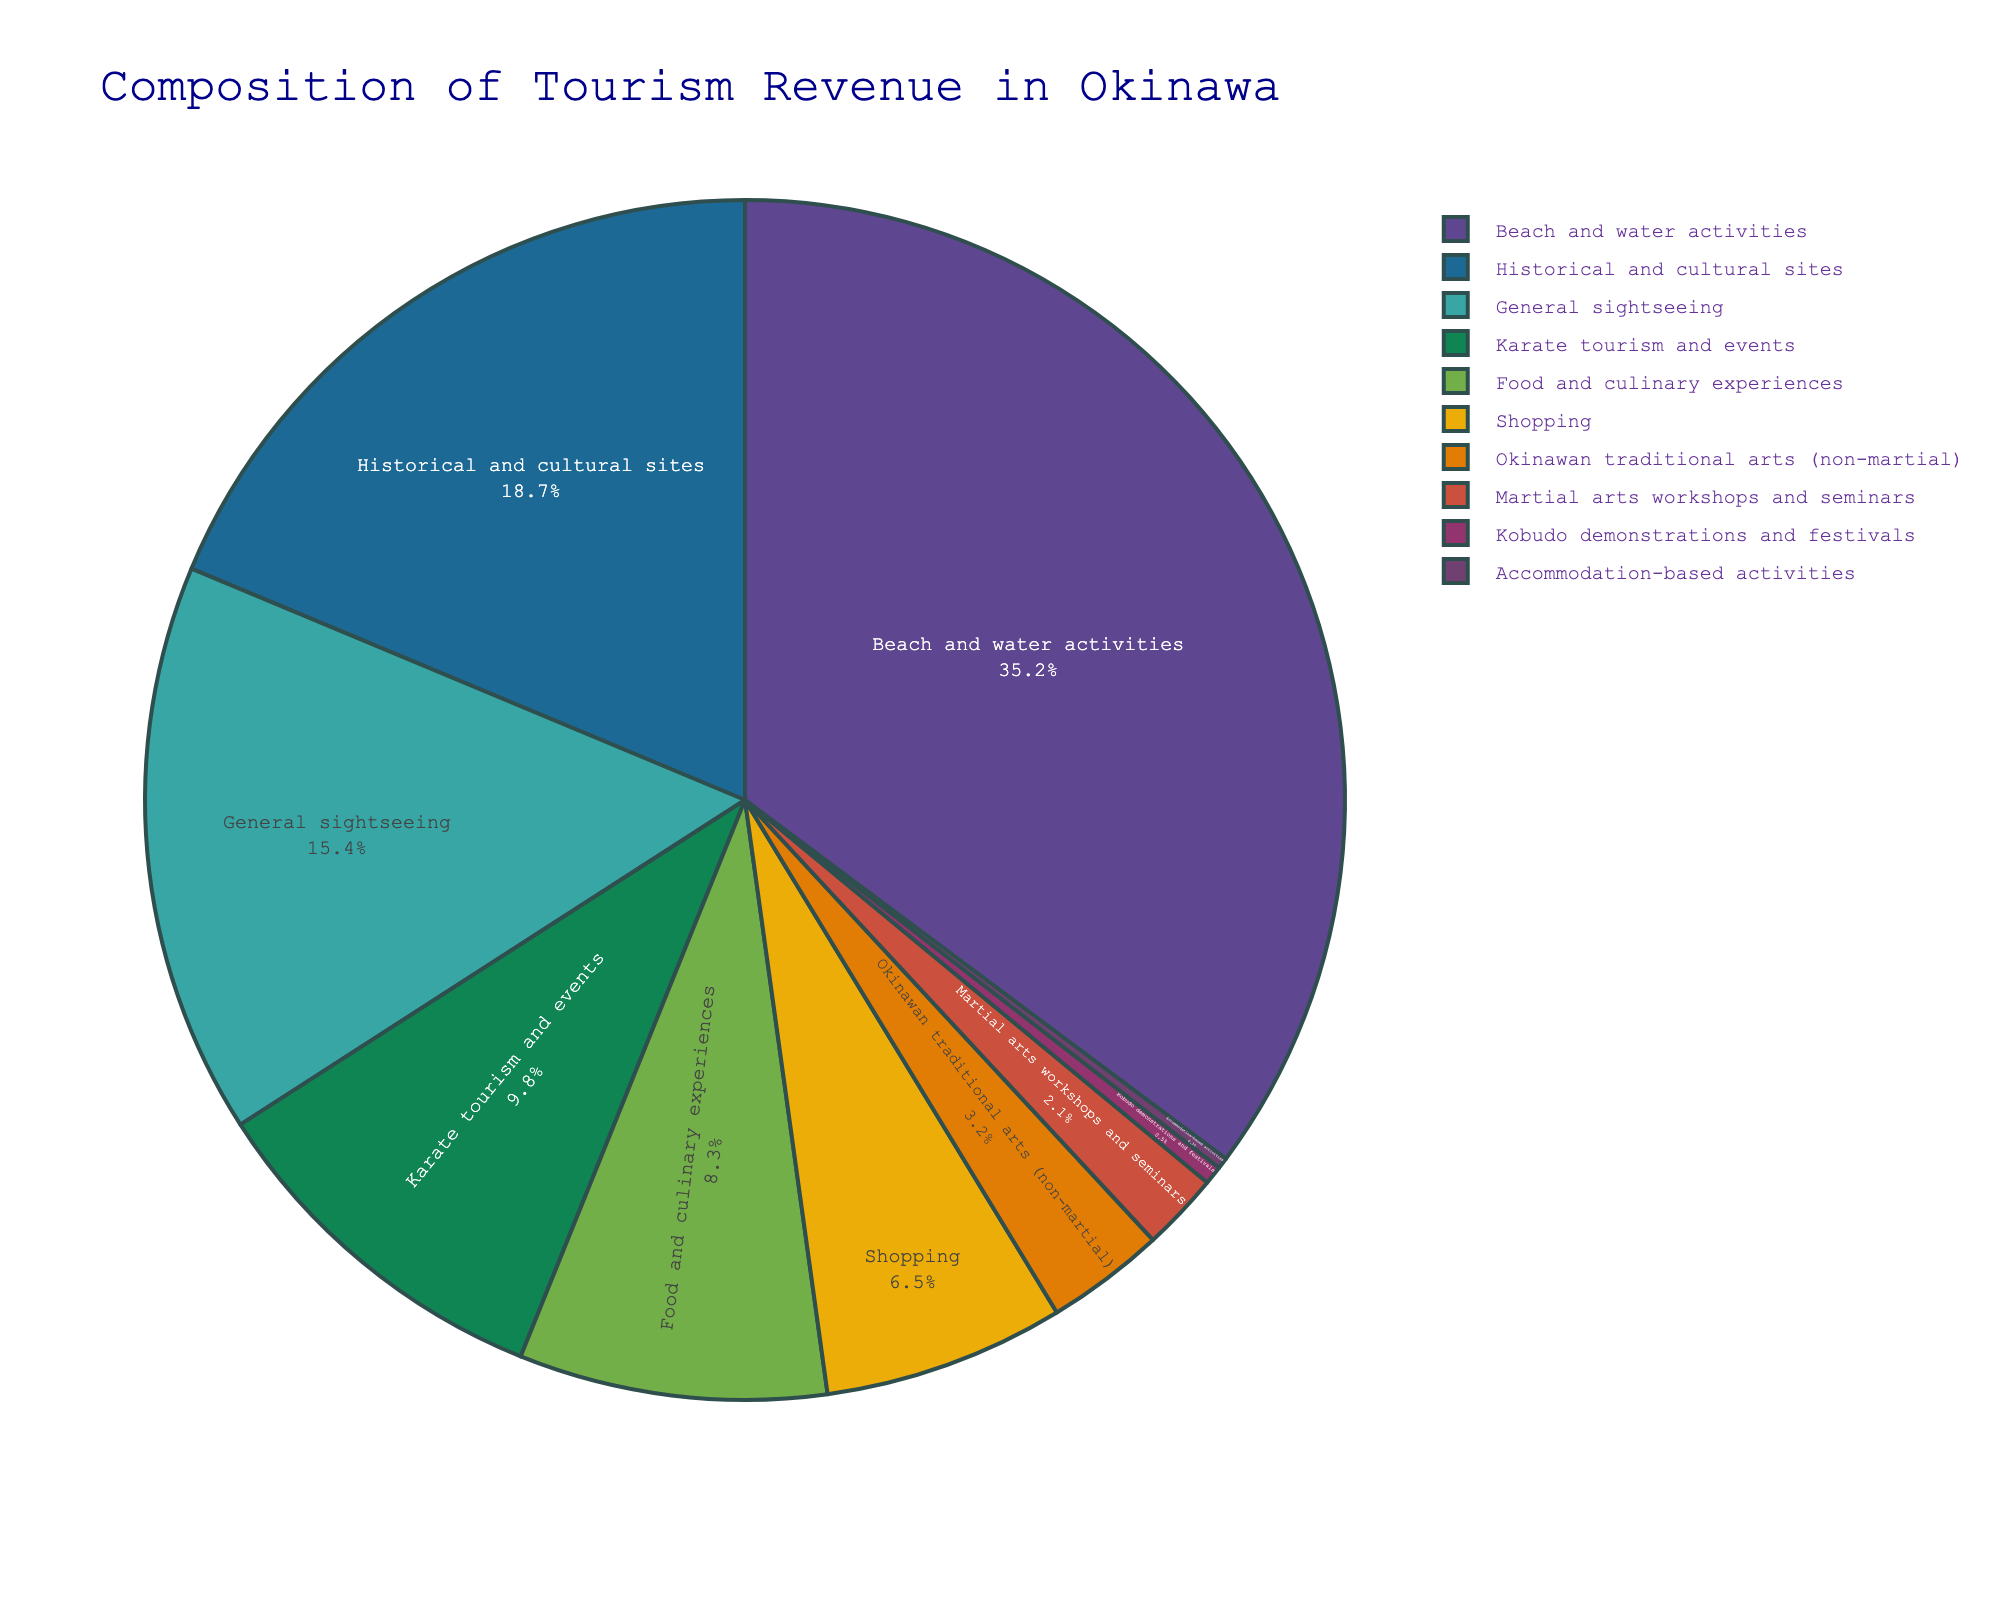What is the combined percentage of revenue from Karate tourism and events, Martial arts workshops and seminars, and Kobudo demonstrations and festivals? Add the percentages for Karate tourism and events (9.8), Martial arts workshops and seminars (2.1), and Kobudo demonstrations and festivals (0.5). The total is 9.8 + 2.1 + 0.5 = 12.4.
Answer: 12.4 Which category contributes the most to tourism revenue in Okinawa? Look at the section of the pie chart with the largest slice labeled with the percentage. Beach and water activities have the highest percentage at 35.2%.
Answer: Beach and water activities How much more revenue does Beach and water activities generate compared to Karate tourism and events? Subtract the percentage of Karate tourism and events (9.8) from the percentage of Beach and water activities (35.2). The difference is 35.2 - 9.8 = 25.4.
Answer: 25.4 What is the total percentage of revenue generated by Historical and cultural sites and General sightseeing? Add the percentages for Historical and cultural sites (18.7) and General sightseeing (15.4). The total is 18.7 + 15.4 = 34.1.
Answer: 34.1 Rank the contributions from highest to lowest among all martial arts-related categories shown in the pie chart. The martial arts-related categories in the chart are Karate tourism and events (9.8), Martial arts workshops and seminars (2.1), and Kobudo demonstrations and festivals (0.5). Rank them from highest to lowest: 9.8, 2.1, 0.5.
Answer: Karate tourism and events, Martial arts workshops and seminars, Kobudo demonstrations and festivals What percentage of revenue does Shopping contribute, and how does it compare with the percentage from Food and culinary experiences? Shopping contributes 6.5%. Food and culinary experiences contribute 8.3%. To compare, subtract 6.5 from 8.3. The difference is 8.3 - 6.5 = 1.8, meaning Shopping contributes 1.8% less than Food and culinary experiences.
Answer: 6.5; 1.8 less What is the percentage difference between Okinawan traditional arts (non-martial) and Martial arts workshops and seminars? Subtract the percentage of Okinawan traditional arts (non-martial) (3.2) from the percentage of Martial arts workshops and seminars (2.1). The difference is 3.2 - 2.1 = 1.1.
Answer: 1.1 